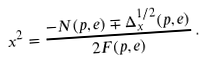<formula> <loc_0><loc_0><loc_500><loc_500>x ^ { 2 } = \frac { - N ( p , e ) \mp \Delta ^ { 1 / 2 } _ { x } ( p , e ) } { 2 F ( p , e ) } \, .</formula> 